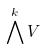<formula> <loc_0><loc_0><loc_500><loc_500>\bigwedge ^ { k } V</formula> 